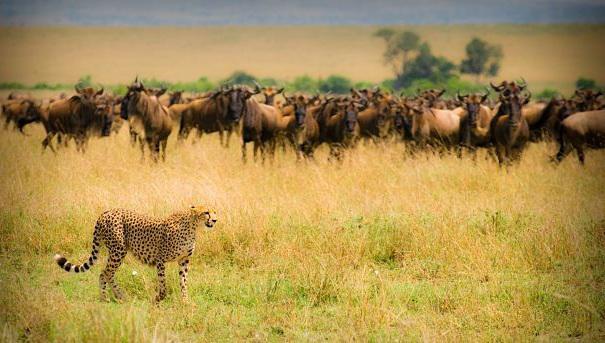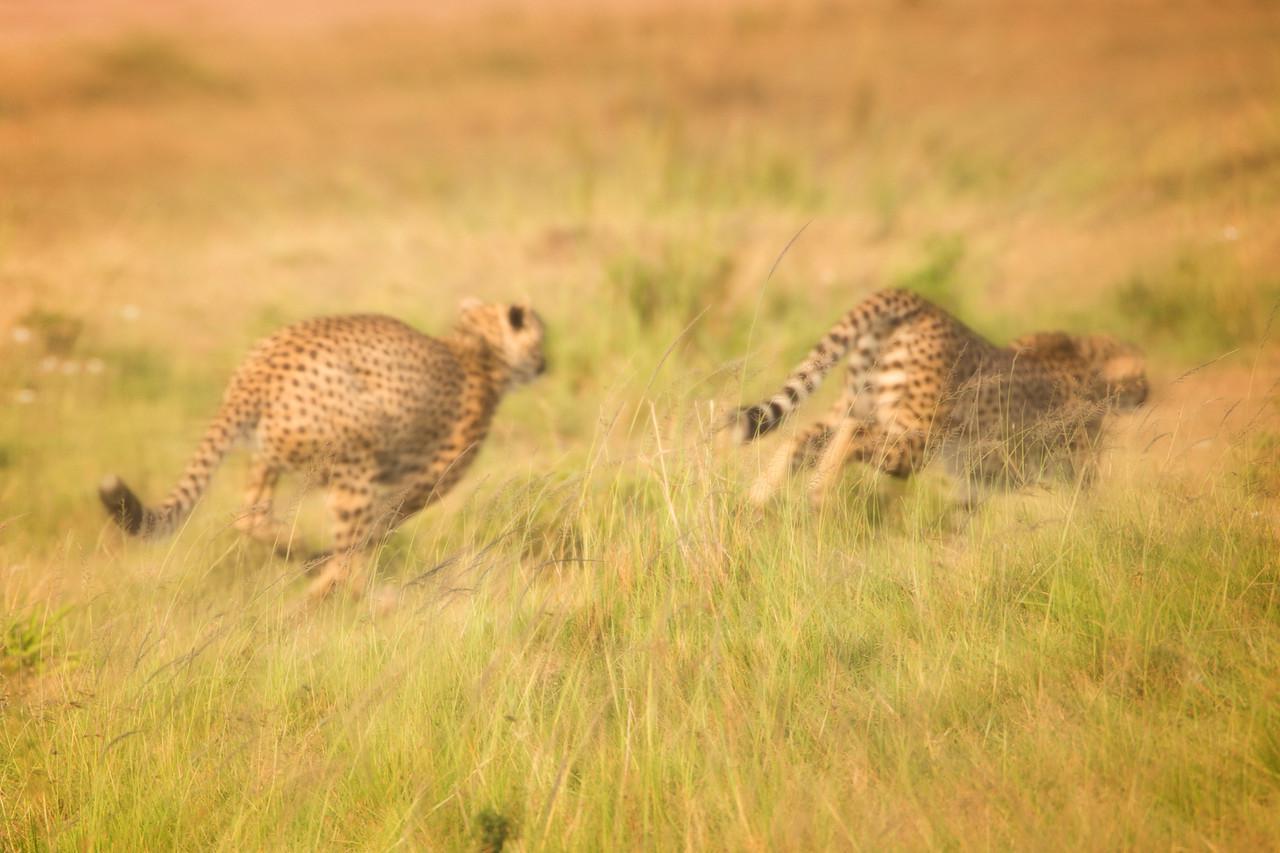The first image is the image on the left, the second image is the image on the right. For the images displayed, is the sentence "Two cheetahs are running." factually correct? Answer yes or no. Yes. 